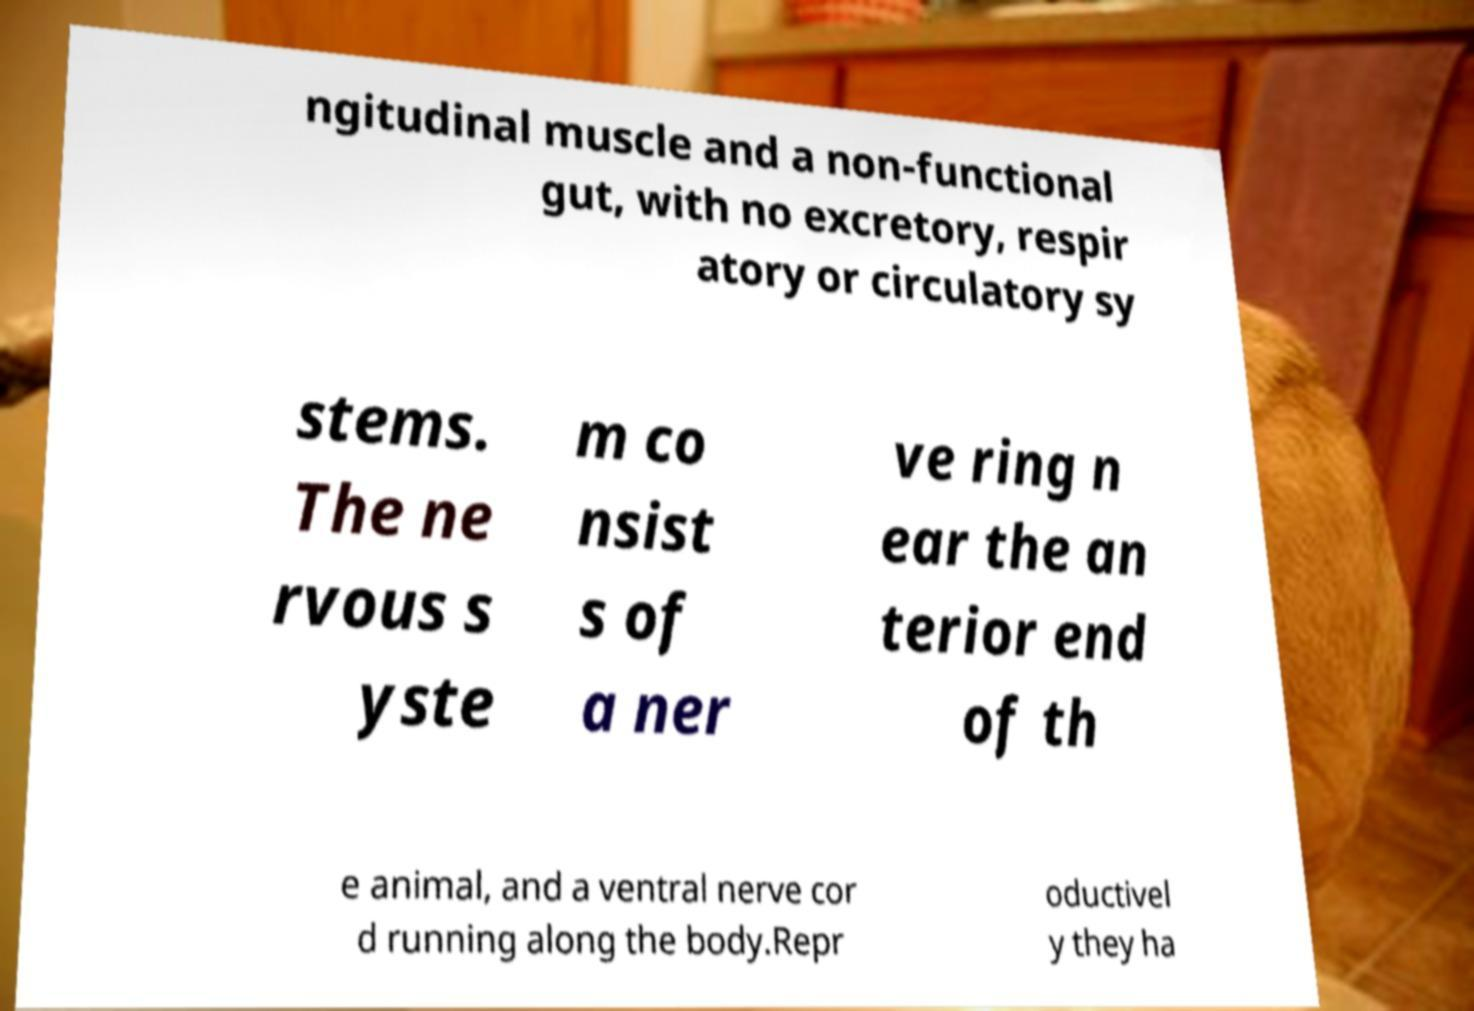Please identify and transcribe the text found in this image. ngitudinal muscle and a non-functional gut, with no excretory, respir atory or circulatory sy stems. The ne rvous s yste m co nsist s of a ner ve ring n ear the an terior end of th e animal, and a ventral nerve cor d running along the body.Repr oductivel y they ha 